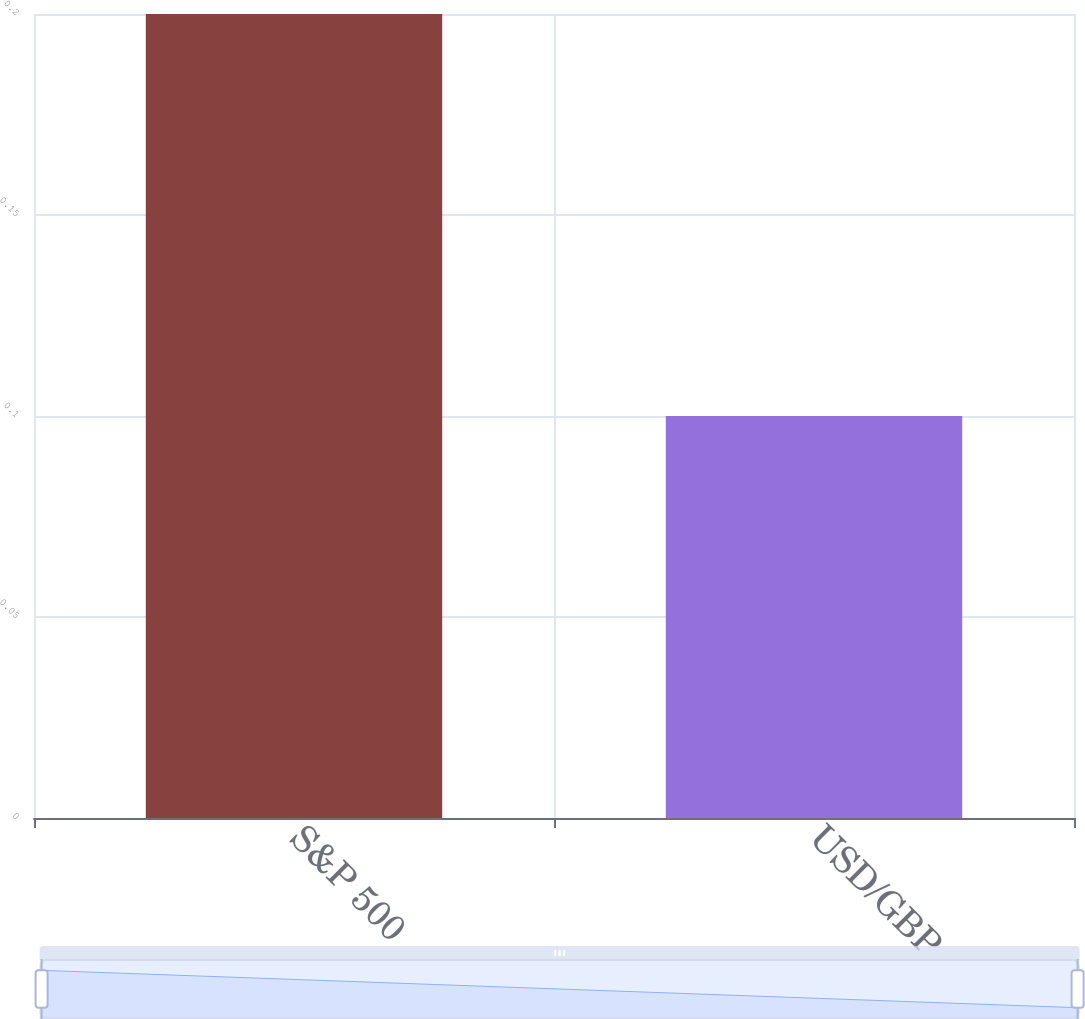Convert chart. <chart><loc_0><loc_0><loc_500><loc_500><bar_chart><fcel>S&P 500<fcel>USD/GBP<nl><fcel>0.2<fcel>0.1<nl></chart> 